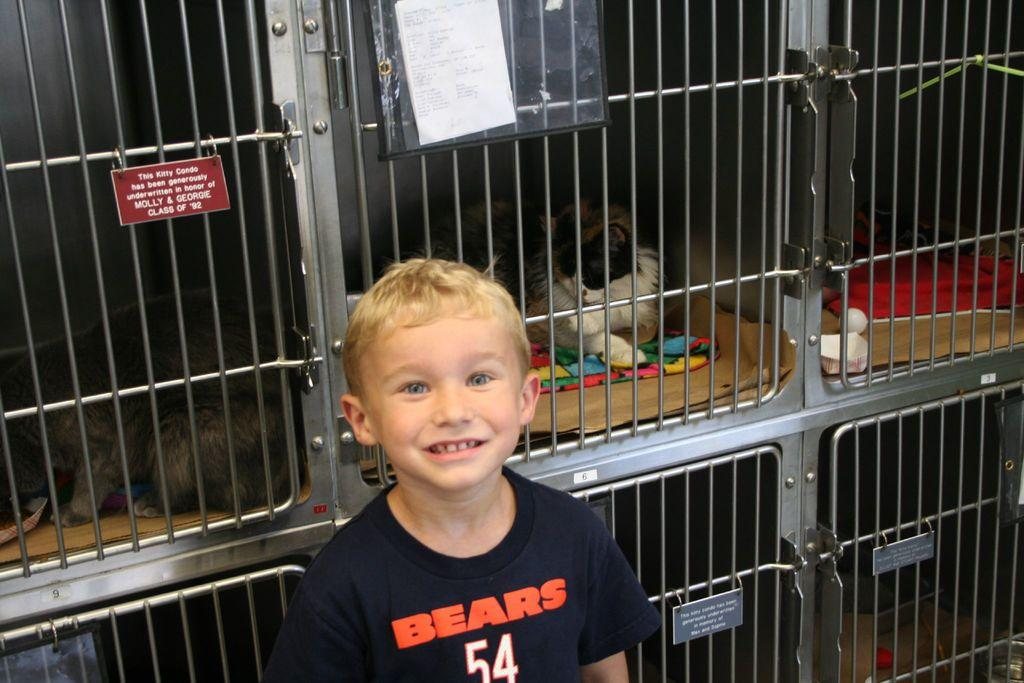What is the main subject in the image? There is a kid in the image. Are there any animals present in the image? Yes, there are two cats in the image. What object can be seen in the background of the image? There is a board in the image. What is posted on the board? There is a paper posted on the board. What change can be observed in the background of the image? There are changes visible in the background of the image. What color is the sweater worn by the girls in the image? There are no girls present in the image, only a kid and two cats. How many boots can be seen in the image? There are no boots visible in the image. 